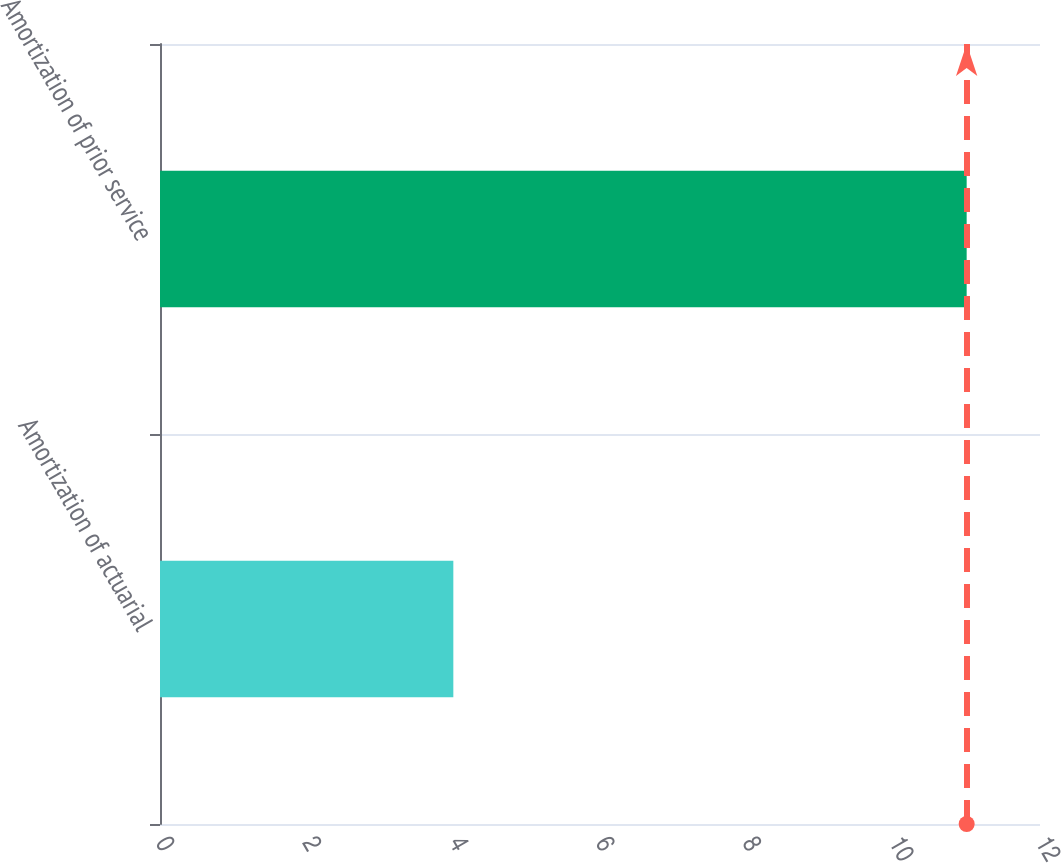Convert chart to OTSL. <chart><loc_0><loc_0><loc_500><loc_500><bar_chart><fcel>Amortization of actuarial<fcel>Amortization of prior service<nl><fcel>4<fcel>11<nl></chart> 